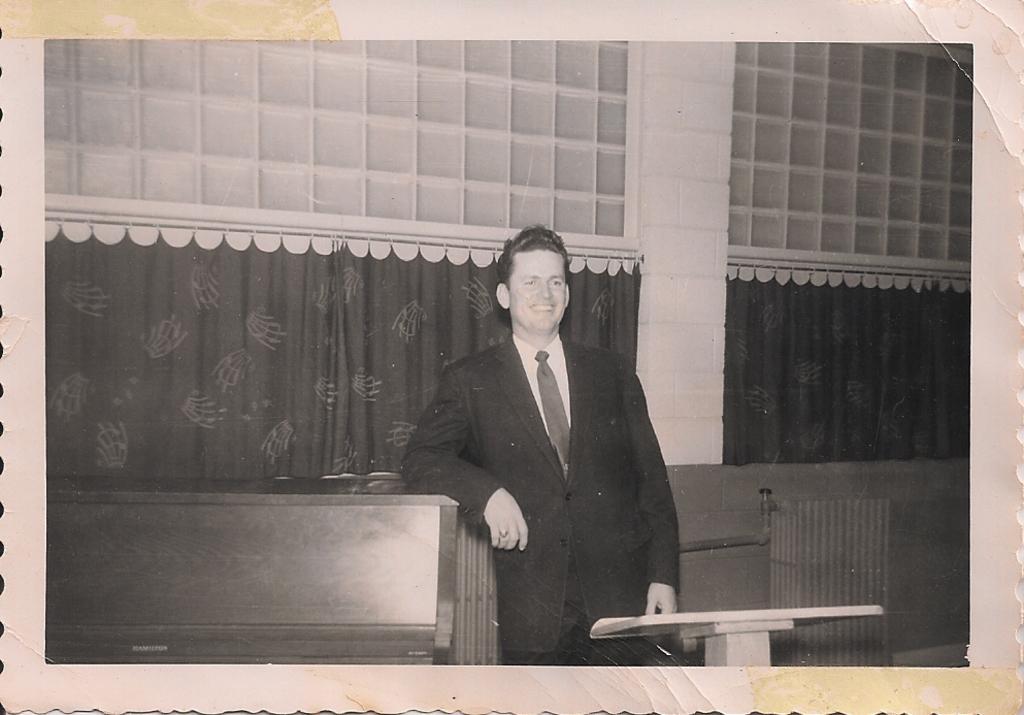How would you summarize this image in a sentence or two? In this image I can see the person standing, background I can see few curtains and the image is in black and white. 